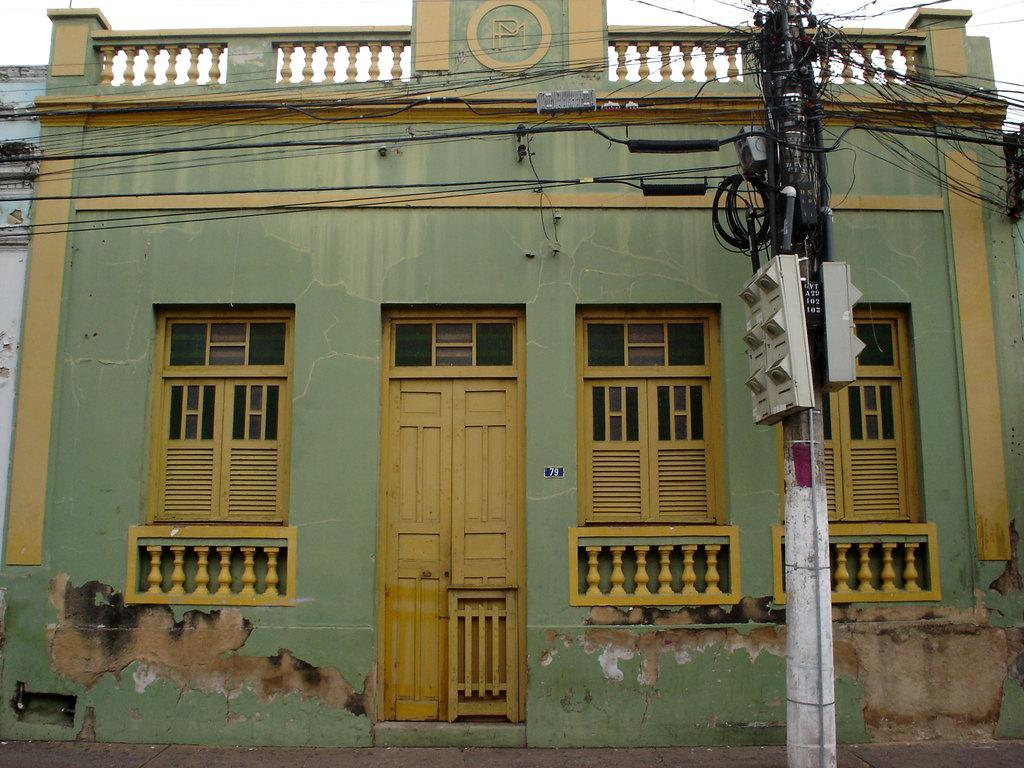What type of structure is present in the image? There is a building in the image. What else can be seen in the image besides the building? There is a pole with wires in the image. What are the white colored objects on the pole? The white colored objects on the pole are likely insulators or other electrical components. What is visible in the background of the image? The sky is visible in the image. What type of impulse can be seen affecting the building in the image? There is no impulse affecting the building in the image; it appears to be stationary. 